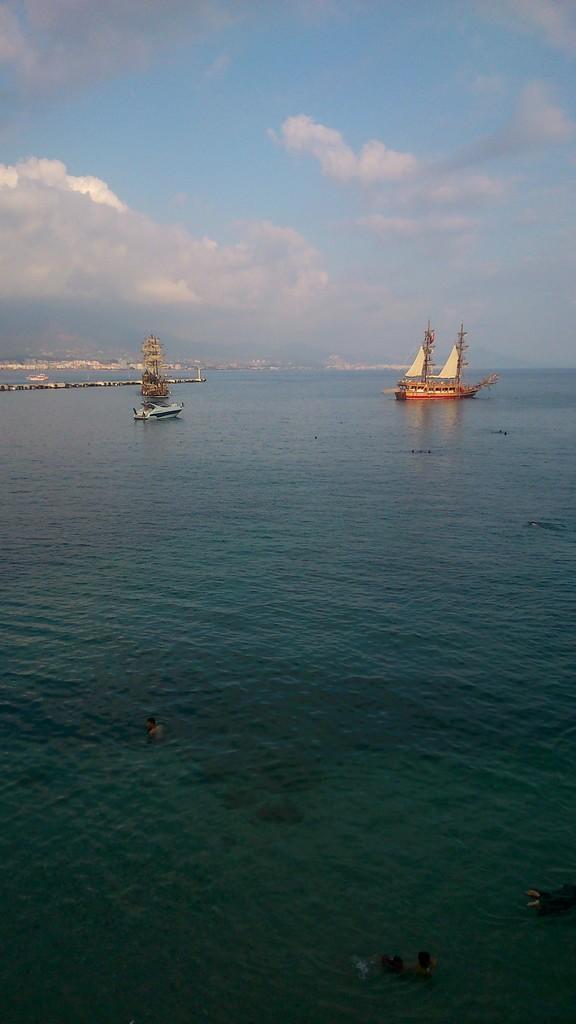Please provide a concise description of this image. There is water surface in the foreground area of the image, there are ships, it seems like buildings and the sky in the background. 